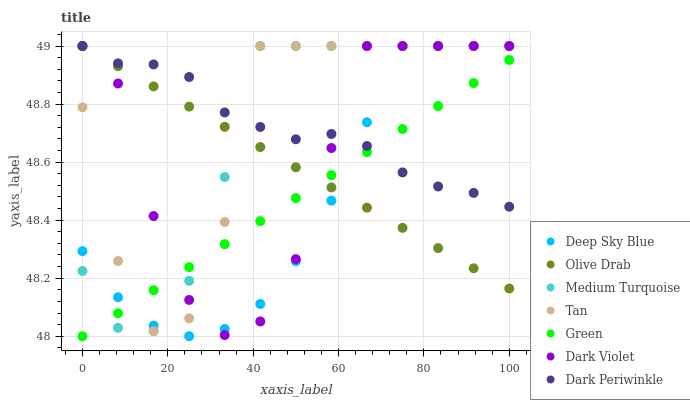Does Deep Sky Blue have the minimum area under the curve?
Answer yes or no. Yes. Does Tan have the maximum area under the curve?
Answer yes or no. Yes. Does Dark Violet have the minimum area under the curve?
Answer yes or no. No. Does Dark Violet have the maximum area under the curve?
Answer yes or no. No. Is Green the smoothest?
Answer yes or no. Yes. Is Tan the roughest?
Answer yes or no. Yes. Is Dark Violet the smoothest?
Answer yes or no. No. Is Dark Violet the roughest?
Answer yes or no. No. Does Green have the lowest value?
Answer yes or no. Yes. Does Dark Violet have the lowest value?
Answer yes or no. No. Does Olive Drab have the highest value?
Answer yes or no. Yes. Does Green have the highest value?
Answer yes or no. No. Does Tan intersect Olive Drab?
Answer yes or no. Yes. Is Tan less than Olive Drab?
Answer yes or no. No. Is Tan greater than Olive Drab?
Answer yes or no. No. 